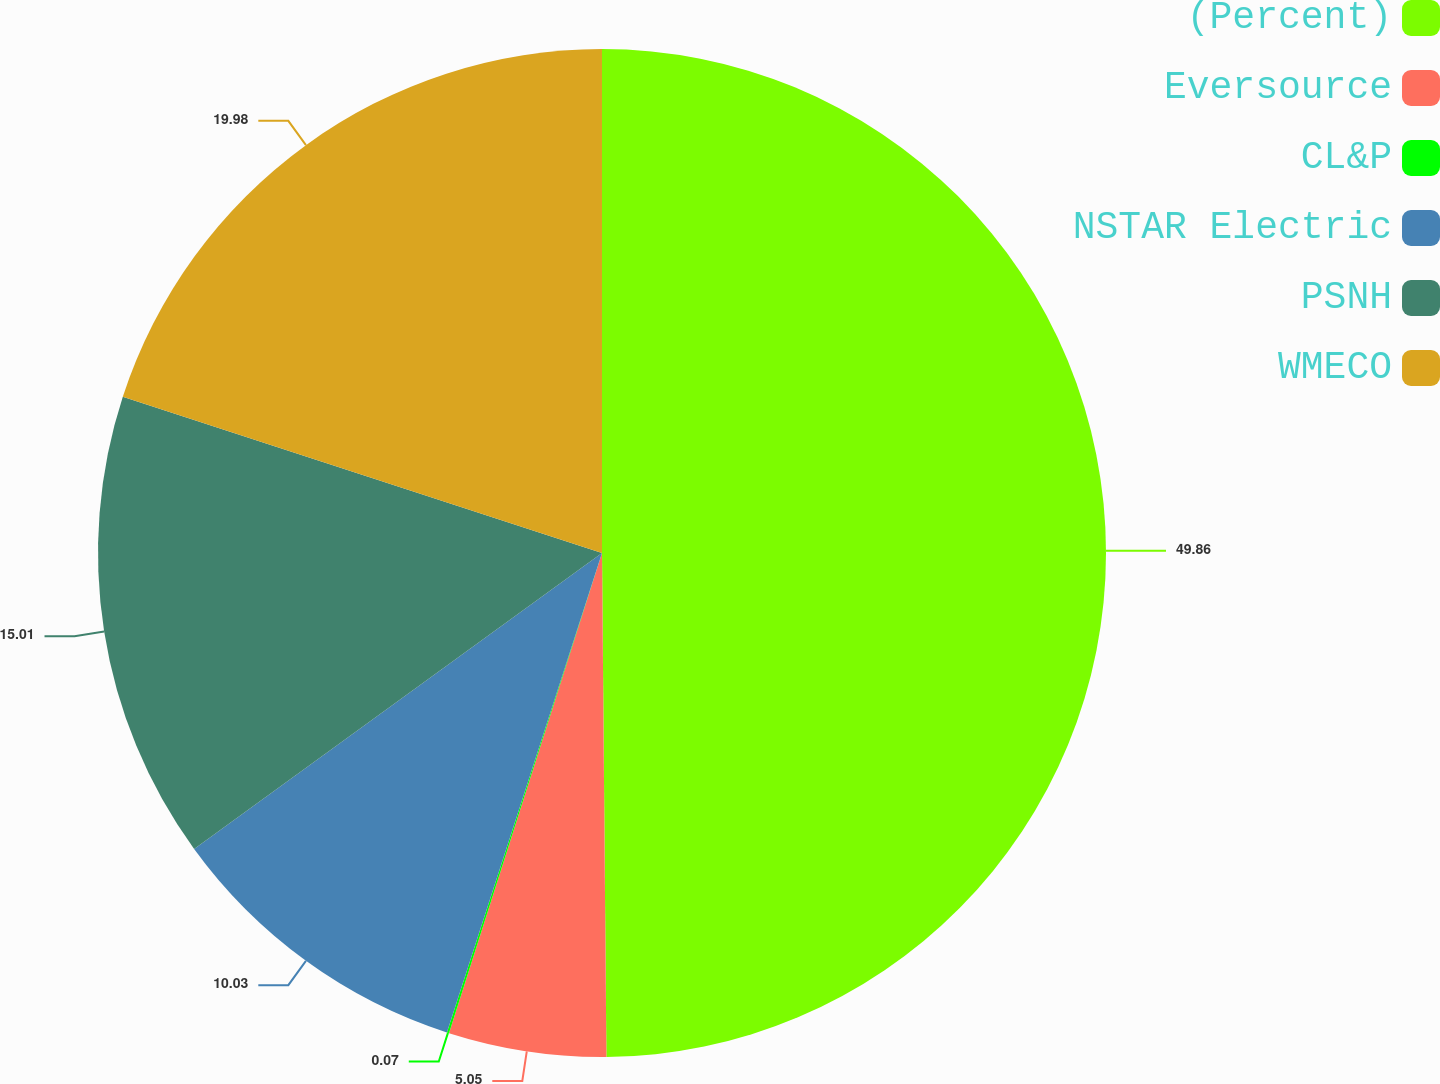Convert chart to OTSL. <chart><loc_0><loc_0><loc_500><loc_500><pie_chart><fcel>(Percent)<fcel>Eversource<fcel>CL&P<fcel>NSTAR Electric<fcel>PSNH<fcel>WMECO<nl><fcel>49.87%<fcel>5.05%<fcel>0.07%<fcel>10.03%<fcel>15.01%<fcel>19.99%<nl></chart> 